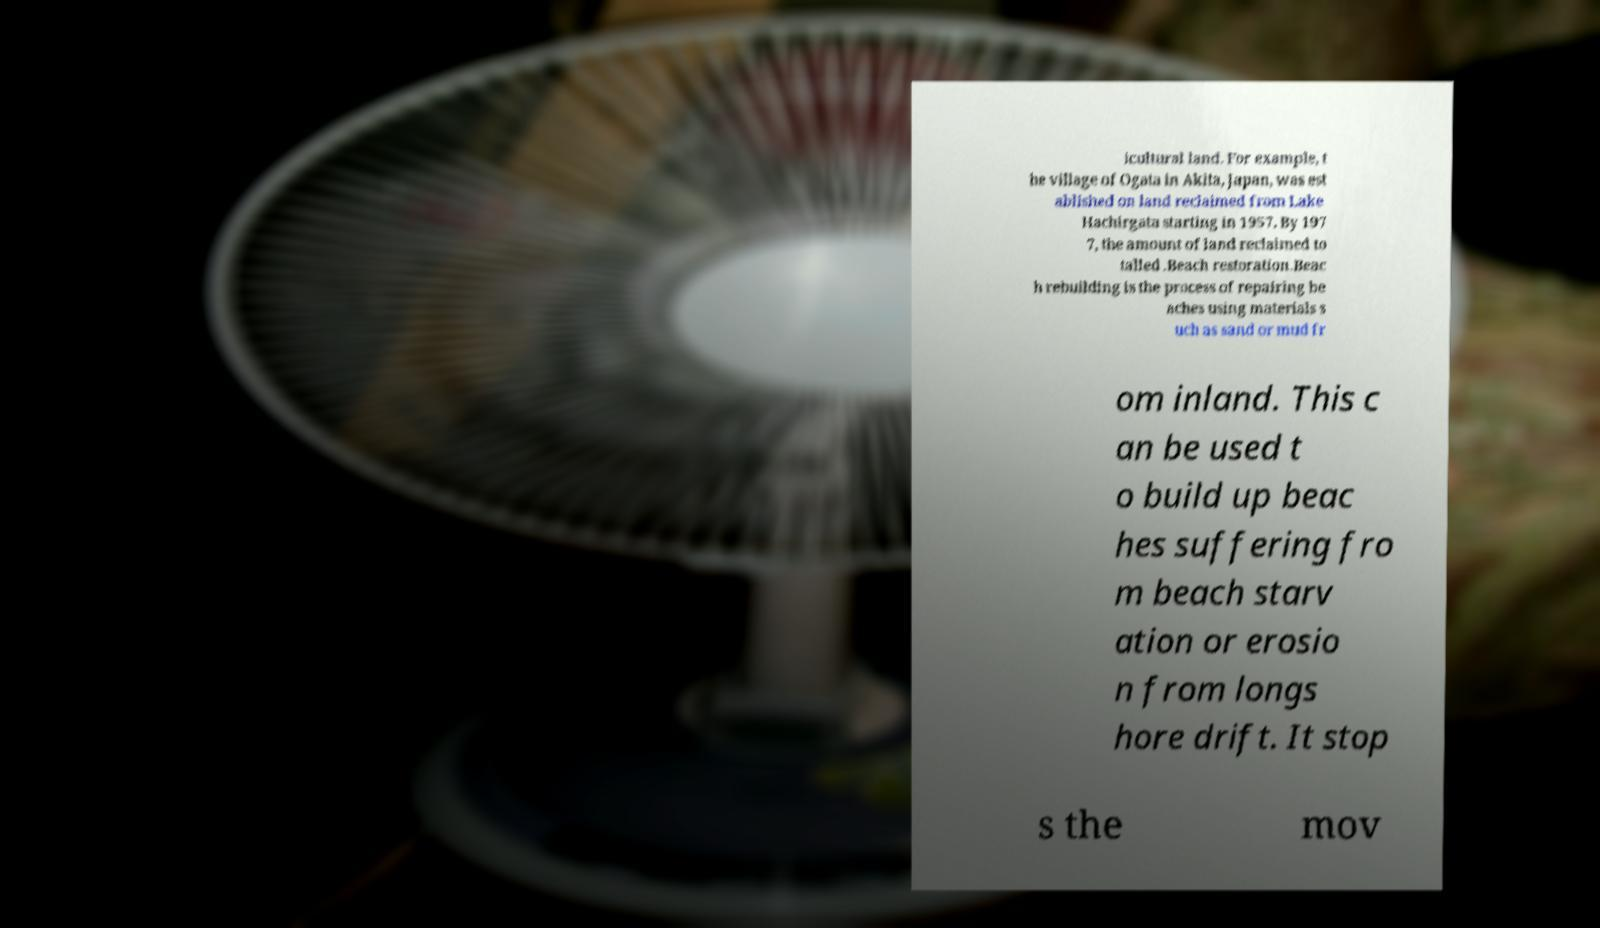Please identify and transcribe the text found in this image. icultural land. For example, t he village of Ogata in Akita, Japan, was est ablished on land reclaimed from Lake Hachirgata starting in 1957. By 197 7, the amount of land reclaimed to talled .Beach restoration.Beac h rebuilding is the process of repairing be aches using materials s uch as sand or mud fr om inland. This c an be used t o build up beac hes suffering fro m beach starv ation or erosio n from longs hore drift. It stop s the mov 